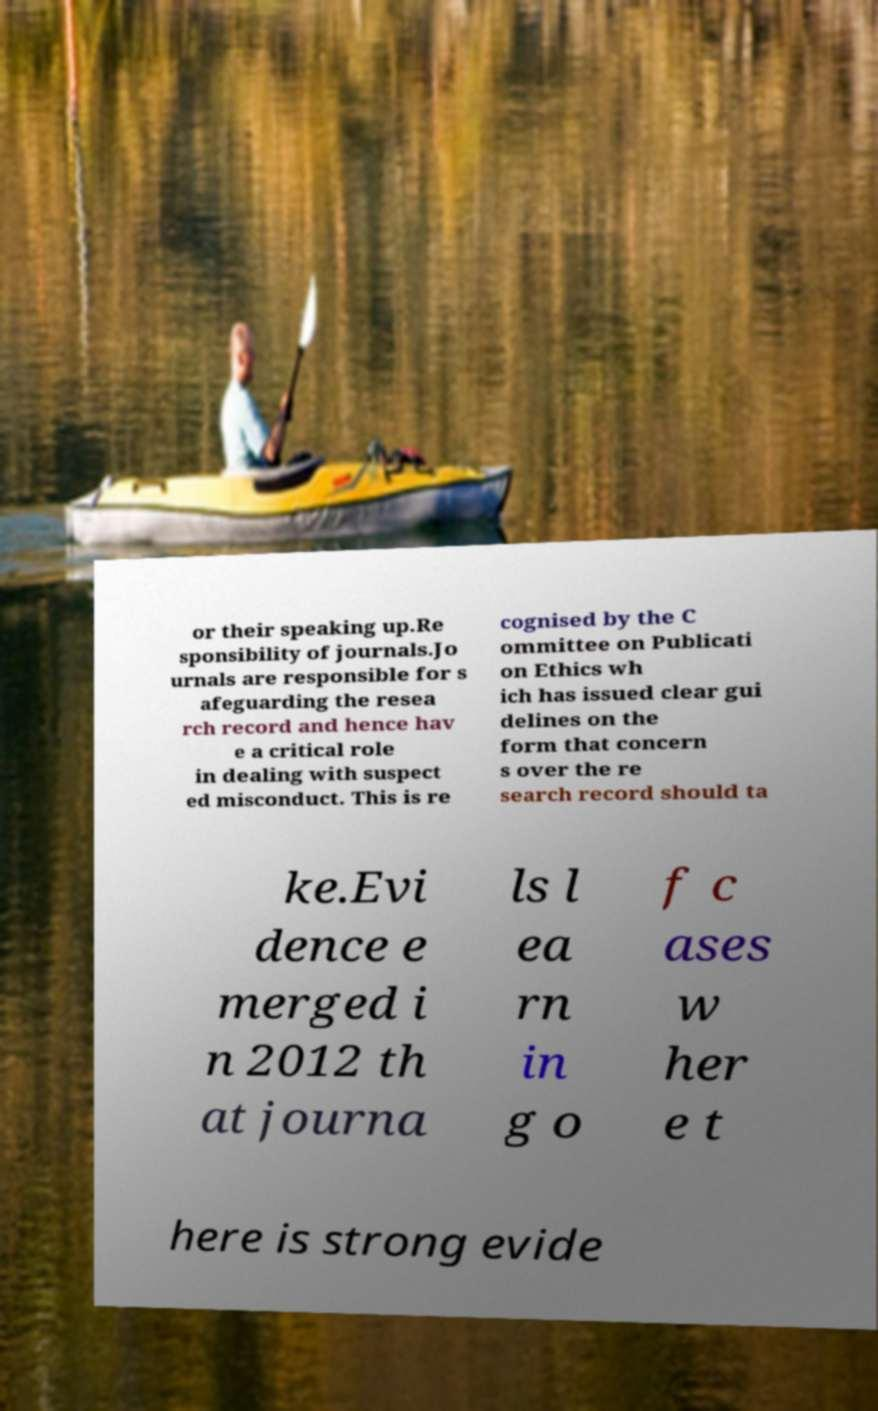For documentation purposes, I need the text within this image transcribed. Could you provide that? or their speaking up.Re sponsibility of journals.Jo urnals are responsible for s afeguarding the resea rch record and hence hav e a critical role in dealing with suspect ed misconduct. This is re cognised by the C ommittee on Publicati on Ethics wh ich has issued clear gui delines on the form that concern s over the re search record should ta ke.Evi dence e merged i n 2012 th at journa ls l ea rn in g o f c ases w her e t here is strong evide 